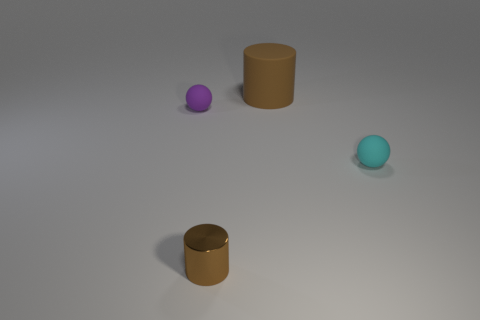Add 1 tiny brown shiny things. How many objects exist? 5 Add 2 large matte cylinders. How many large matte cylinders exist? 3 Subtract 0 red cylinders. How many objects are left? 4 Subtract all matte cylinders. Subtract all tiny brown cylinders. How many objects are left? 2 Add 4 brown shiny objects. How many brown shiny objects are left? 5 